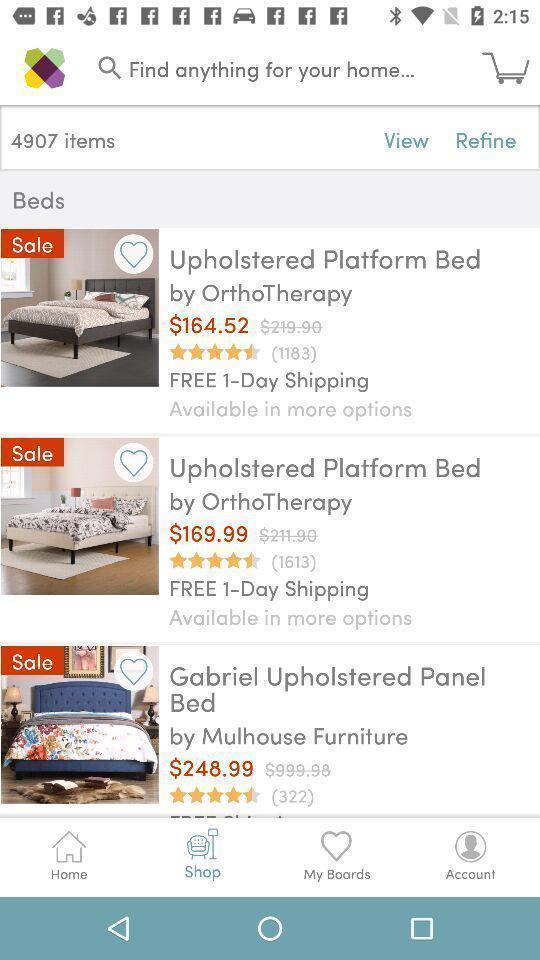Provide a detailed account of this screenshot. Page showing product from a shopping app. 